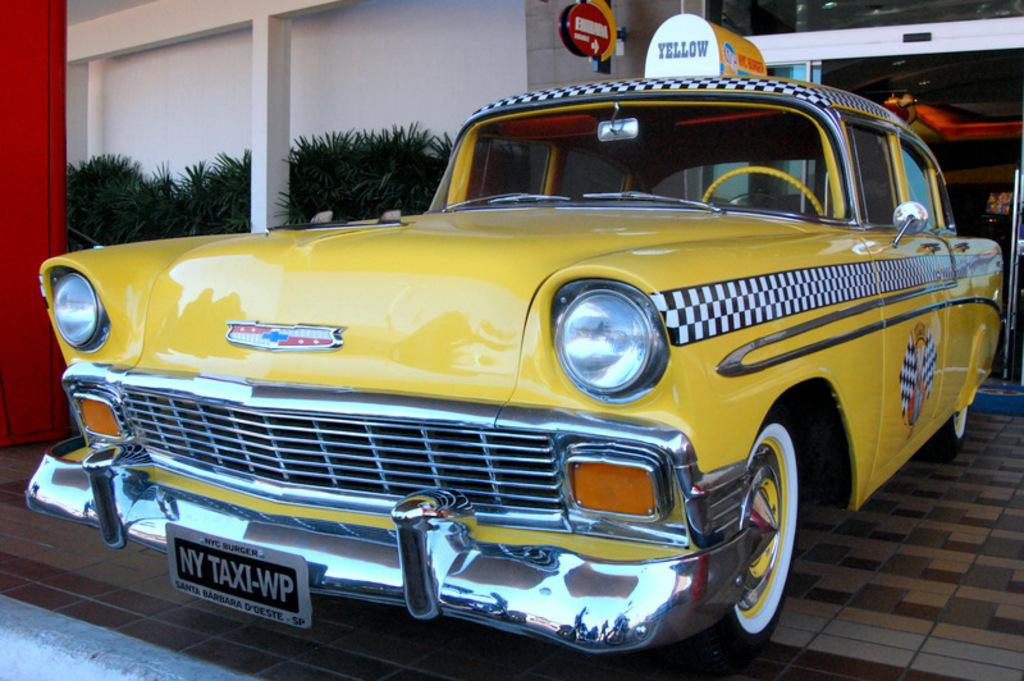<image>
Present a compact description of the photo's key features. A yellow Taxi colored yellow with black and white checks running down the side of the car. 